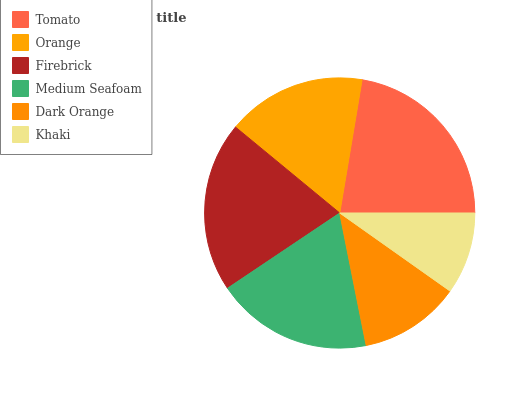Is Khaki the minimum?
Answer yes or no. Yes. Is Tomato the maximum?
Answer yes or no. Yes. Is Orange the minimum?
Answer yes or no. No. Is Orange the maximum?
Answer yes or no. No. Is Tomato greater than Orange?
Answer yes or no. Yes. Is Orange less than Tomato?
Answer yes or no. Yes. Is Orange greater than Tomato?
Answer yes or no. No. Is Tomato less than Orange?
Answer yes or no. No. Is Medium Seafoam the high median?
Answer yes or no. Yes. Is Orange the low median?
Answer yes or no. Yes. Is Khaki the high median?
Answer yes or no. No. Is Khaki the low median?
Answer yes or no. No. 